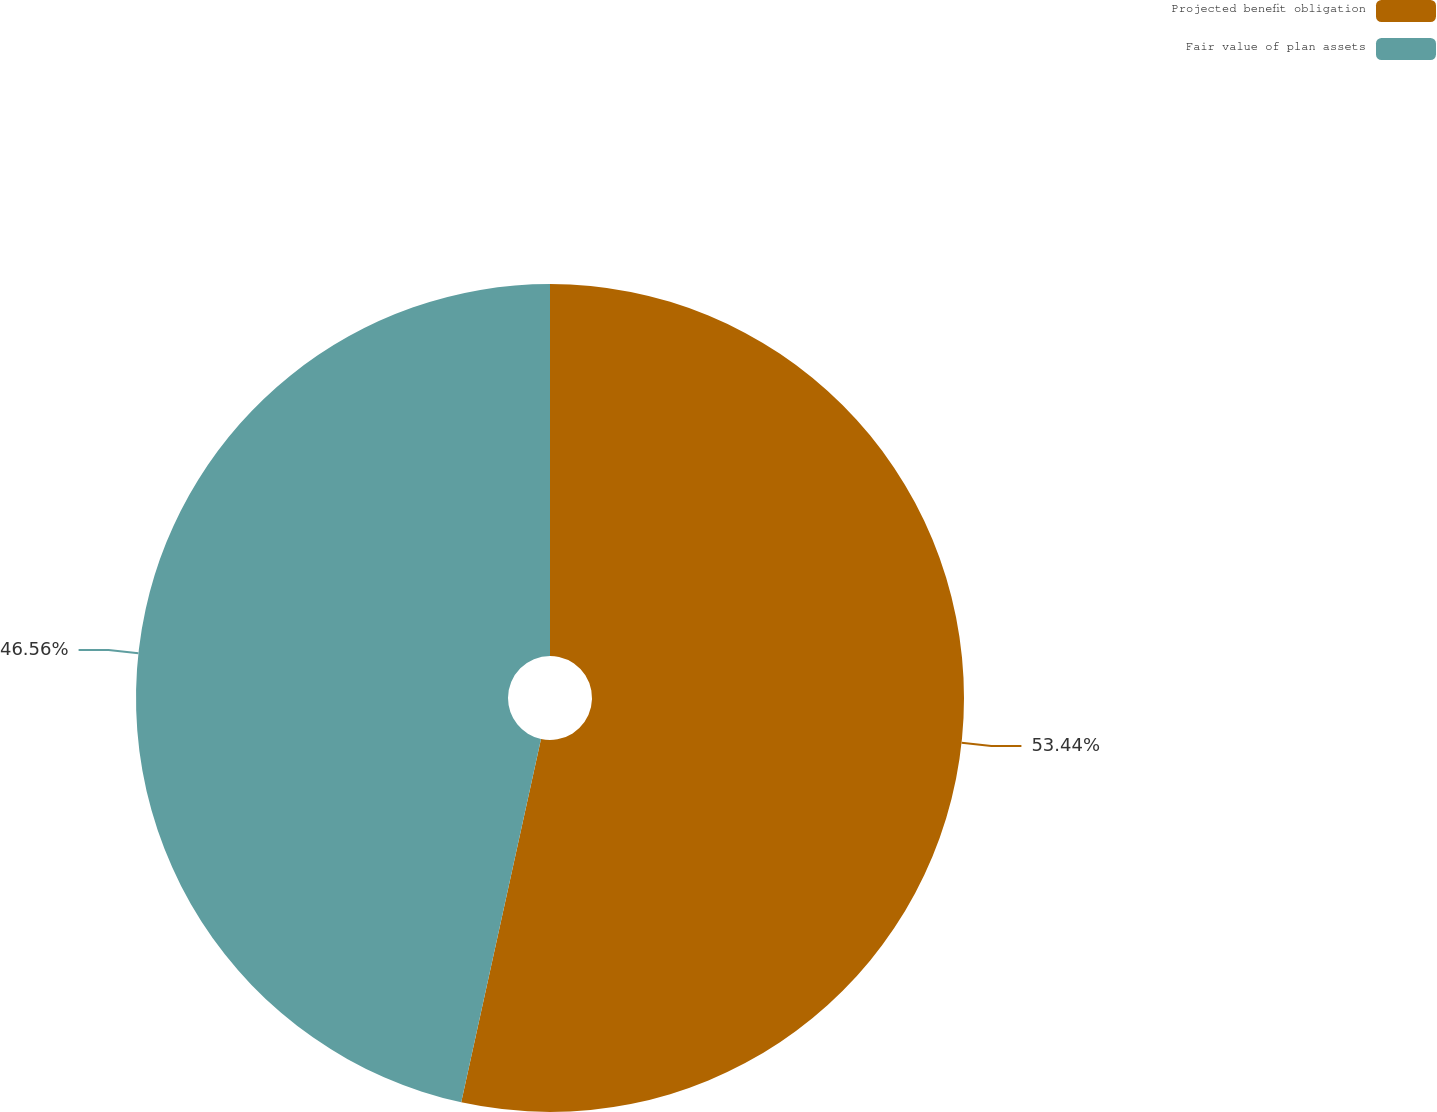Convert chart to OTSL. <chart><loc_0><loc_0><loc_500><loc_500><pie_chart><fcel>Projected benefit obligation<fcel>Fair value of plan assets<nl><fcel>53.44%<fcel>46.56%<nl></chart> 